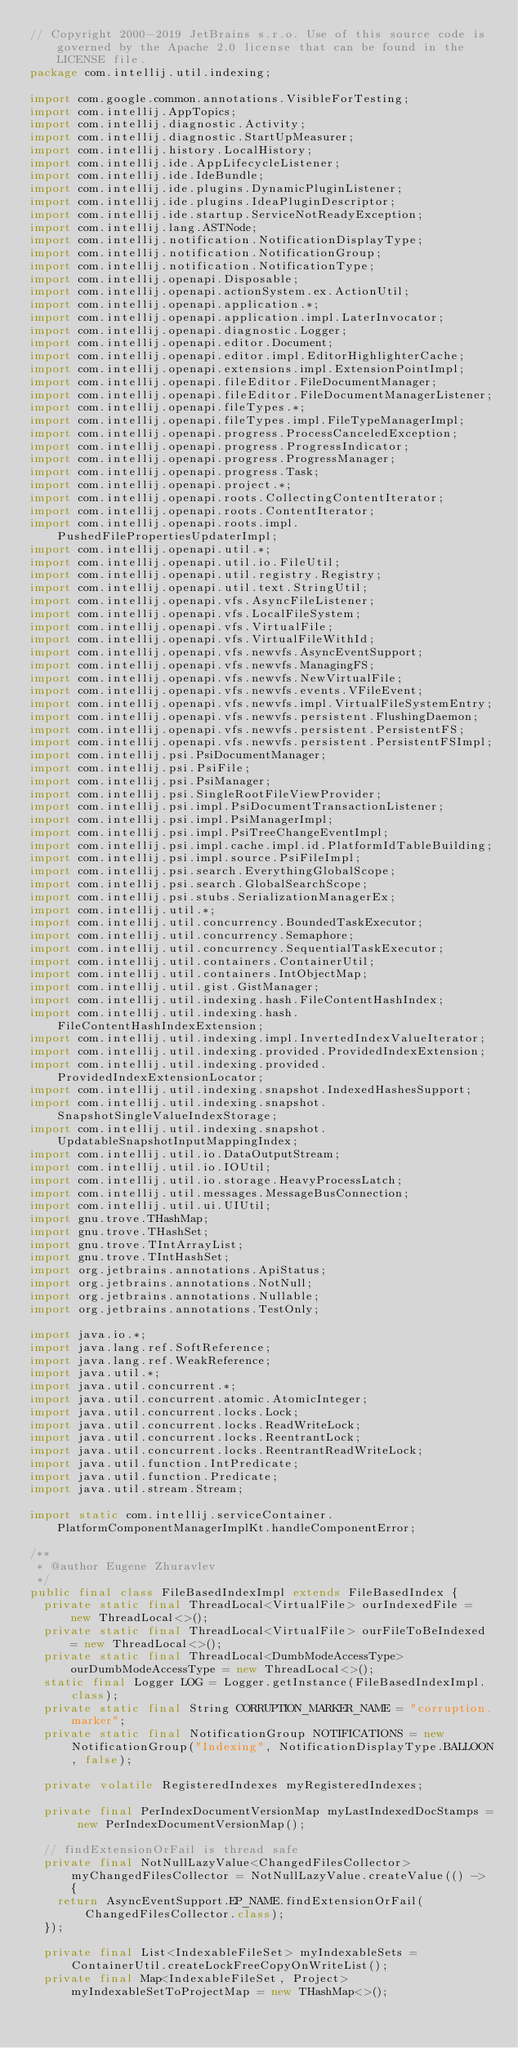Convert code to text. <code><loc_0><loc_0><loc_500><loc_500><_Java_>// Copyright 2000-2019 JetBrains s.r.o. Use of this source code is governed by the Apache 2.0 license that can be found in the LICENSE file.
package com.intellij.util.indexing;

import com.google.common.annotations.VisibleForTesting;
import com.intellij.AppTopics;
import com.intellij.diagnostic.Activity;
import com.intellij.diagnostic.StartUpMeasurer;
import com.intellij.history.LocalHistory;
import com.intellij.ide.AppLifecycleListener;
import com.intellij.ide.IdeBundle;
import com.intellij.ide.plugins.DynamicPluginListener;
import com.intellij.ide.plugins.IdeaPluginDescriptor;
import com.intellij.ide.startup.ServiceNotReadyException;
import com.intellij.lang.ASTNode;
import com.intellij.notification.NotificationDisplayType;
import com.intellij.notification.NotificationGroup;
import com.intellij.notification.NotificationType;
import com.intellij.openapi.Disposable;
import com.intellij.openapi.actionSystem.ex.ActionUtil;
import com.intellij.openapi.application.*;
import com.intellij.openapi.application.impl.LaterInvocator;
import com.intellij.openapi.diagnostic.Logger;
import com.intellij.openapi.editor.Document;
import com.intellij.openapi.editor.impl.EditorHighlighterCache;
import com.intellij.openapi.extensions.impl.ExtensionPointImpl;
import com.intellij.openapi.fileEditor.FileDocumentManager;
import com.intellij.openapi.fileEditor.FileDocumentManagerListener;
import com.intellij.openapi.fileTypes.*;
import com.intellij.openapi.fileTypes.impl.FileTypeManagerImpl;
import com.intellij.openapi.progress.ProcessCanceledException;
import com.intellij.openapi.progress.ProgressIndicator;
import com.intellij.openapi.progress.ProgressManager;
import com.intellij.openapi.progress.Task;
import com.intellij.openapi.project.*;
import com.intellij.openapi.roots.CollectingContentIterator;
import com.intellij.openapi.roots.ContentIterator;
import com.intellij.openapi.roots.impl.PushedFilePropertiesUpdaterImpl;
import com.intellij.openapi.util.*;
import com.intellij.openapi.util.io.FileUtil;
import com.intellij.openapi.util.registry.Registry;
import com.intellij.openapi.util.text.StringUtil;
import com.intellij.openapi.vfs.AsyncFileListener;
import com.intellij.openapi.vfs.LocalFileSystem;
import com.intellij.openapi.vfs.VirtualFile;
import com.intellij.openapi.vfs.VirtualFileWithId;
import com.intellij.openapi.vfs.newvfs.AsyncEventSupport;
import com.intellij.openapi.vfs.newvfs.ManagingFS;
import com.intellij.openapi.vfs.newvfs.NewVirtualFile;
import com.intellij.openapi.vfs.newvfs.events.VFileEvent;
import com.intellij.openapi.vfs.newvfs.impl.VirtualFileSystemEntry;
import com.intellij.openapi.vfs.newvfs.persistent.FlushingDaemon;
import com.intellij.openapi.vfs.newvfs.persistent.PersistentFS;
import com.intellij.openapi.vfs.newvfs.persistent.PersistentFSImpl;
import com.intellij.psi.PsiDocumentManager;
import com.intellij.psi.PsiFile;
import com.intellij.psi.PsiManager;
import com.intellij.psi.SingleRootFileViewProvider;
import com.intellij.psi.impl.PsiDocumentTransactionListener;
import com.intellij.psi.impl.PsiManagerImpl;
import com.intellij.psi.impl.PsiTreeChangeEventImpl;
import com.intellij.psi.impl.cache.impl.id.PlatformIdTableBuilding;
import com.intellij.psi.impl.source.PsiFileImpl;
import com.intellij.psi.search.EverythingGlobalScope;
import com.intellij.psi.search.GlobalSearchScope;
import com.intellij.psi.stubs.SerializationManagerEx;
import com.intellij.util.*;
import com.intellij.util.concurrency.BoundedTaskExecutor;
import com.intellij.util.concurrency.Semaphore;
import com.intellij.util.concurrency.SequentialTaskExecutor;
import com.intellij.util.containers.ContainerUtil;
import com.intellij.util.containers.IntObjectMap;
import com.intellij.util.gist.GistManager;
import com.intellij.util.indexing.hash.FileContentHashIndex;
import com.intellij.util.indexing.hash.FileContentHashIndexExtension;
import com.intellij.util.indexing.impl.InvertedIndexValueIterator;
import com.intellij.util.indexing.provided.ProvidedIndexExtension;
import com.intellij.util.indexing.provided.ProvidedIndexExtensionLocator;
import com.intellij.util.indexing.snapshot.IndexedHashesSupport;
import com.intellij.util.indexing.snapshot.SnapshotSingleValueIndexStorage;
import com.intellij.util.indexing.snapshot.UpdatableSnapshotInputMappingIndex;
import com.intellij.util.io.DataOutputStream;
import com.intellij.util.io.IOUtil;
import com.intellij.util.io.storage.HeavyProcessLatch;
import com.intellij.util.messages.MessageBusConnection;
import com.intellij.util.ui.UIUtil;
import gnu.trove.THashMap;
import gnu.trove.THashSet;
import gnu.trove.TIntArrayList;
import gnu.trove.TIntHashSet;
import org.jetbrains.annotations.ApiStatus;
import org.jetbrains.annotations.NotNull;
import org.jetbrains.annotations.Nullable;
import org.jetbrains.annotations.TestOnly;

import java.io.*;
import java.lang.ref.SoftReference;
import java.lang.ref.WeakReference;
import java.util.*;
import java.util.concurrent.*;
import java.util.concurrent.atomic.AtomicInteger;
import java.util.concurrent.locks.Lock;
import java.util.concurrent.locks.ReadWriteLock;
import java.util.concurrent.locks.ReentrantLock;
import java.util.concurrent.locks.ReentrantReadWriteLock;
import java.util.function.IntPredicate;
import java.util.function.Predicate;
import java.util.stream.Stream;

import static com.intellij.serviceContainer.PlatformComponentManagerImplKt.handleComponentError;

/**
 * @author Eugene Zhuravlev
 */
public final class FileBasedIndexImpl extends FileBasedIndex {
  private static final ThreadLocal<VirtualFile> ourIndexedFile = new ThreadLocal<>();
  private static final ThreadLocal<VirtualFile> ourFileToBeIndexed = new ThreadLocal<>();
  private static final ThreadLocal<DumbModeAccessType> ourDumbModeAccessType = new ThreadLocal<>();
  static final Logger LOG = Logger.getInstance(FileBasedIndexImpl.class);
  private static final String CORRUPTION_MARKER_NAME = "corruption.marker";
  private static final NotificationGroup NOTIFICATIONS = new NotificationGroup("Indexing", NotificationDisplayType.BALLOON, false);

  private volatile RegisteredIndexes myRegisteredIndexes;

  private final PerIndexDocumentVersionMap myLastIndexedDocStamps = new PerIndexDocumentVersionMap();

  // findExtensionOrFail is thread safe
  private final NotNullLazyValue<ChangedFilesCollector> myChangedFilesCollector = NotNullLazyValue.createValue(() -> {
    return AsyncEventSupport.EP_NAME.findExtensionOrFail(ChangedFilesCollector.class);
  });

  private final List<IndexableFileSet> myIndexableSets = ContainerUtil.createLockFreeCopyOnWriteList();
  private final Map<IndexableFileSet, Project> myIndexableSetToProjectMap = new THashMap<>();
</code> 